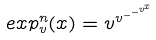<formula> <loc_0><loc_0><loc_500><loc_500>e x p _ { v } ^ { n } ( x ) = v ^ { v ^ { - ^ { - ^ { v ^ { x } } } } }</formula> 